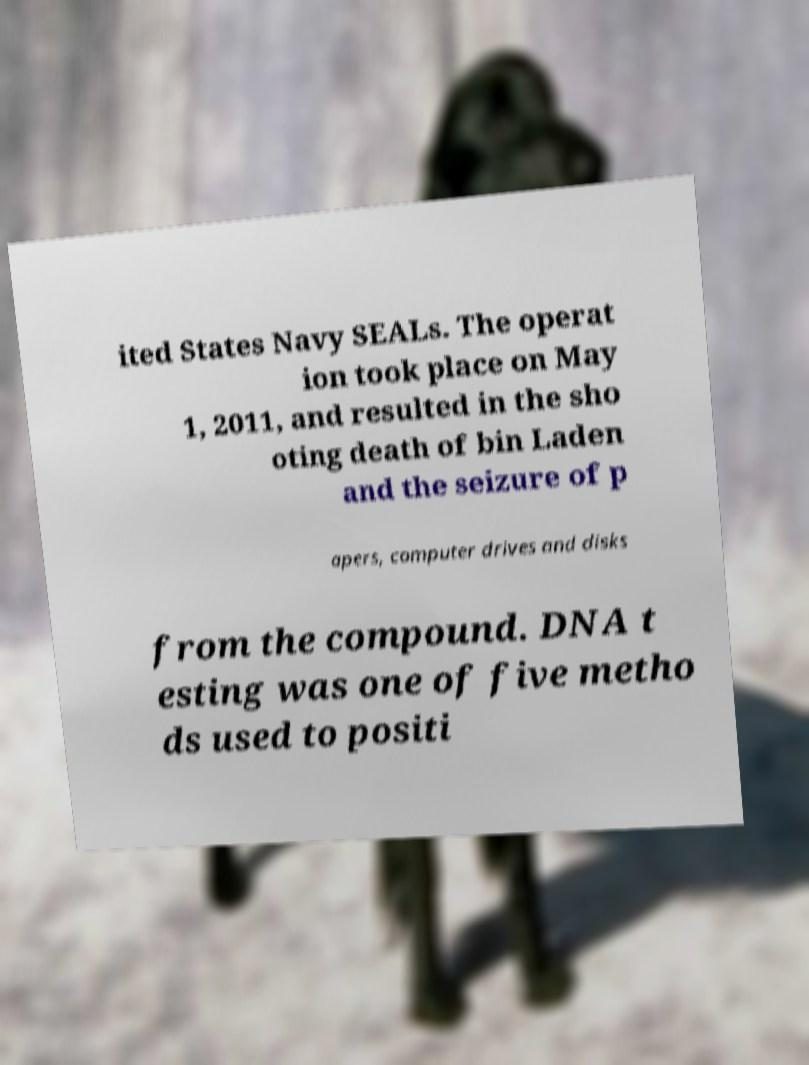Can you read and provide the text displayed in the image?This photo seems to have some interesting text. Can you extract and type it out for me? ited States Navy SEALs. The operat ion took place on May 1, 2011, and resulted in the sho oting death of bin Laden and the seizure of p apers, computer drives and disks from the compound. DNA t esting was one of five metho ds used to positi 